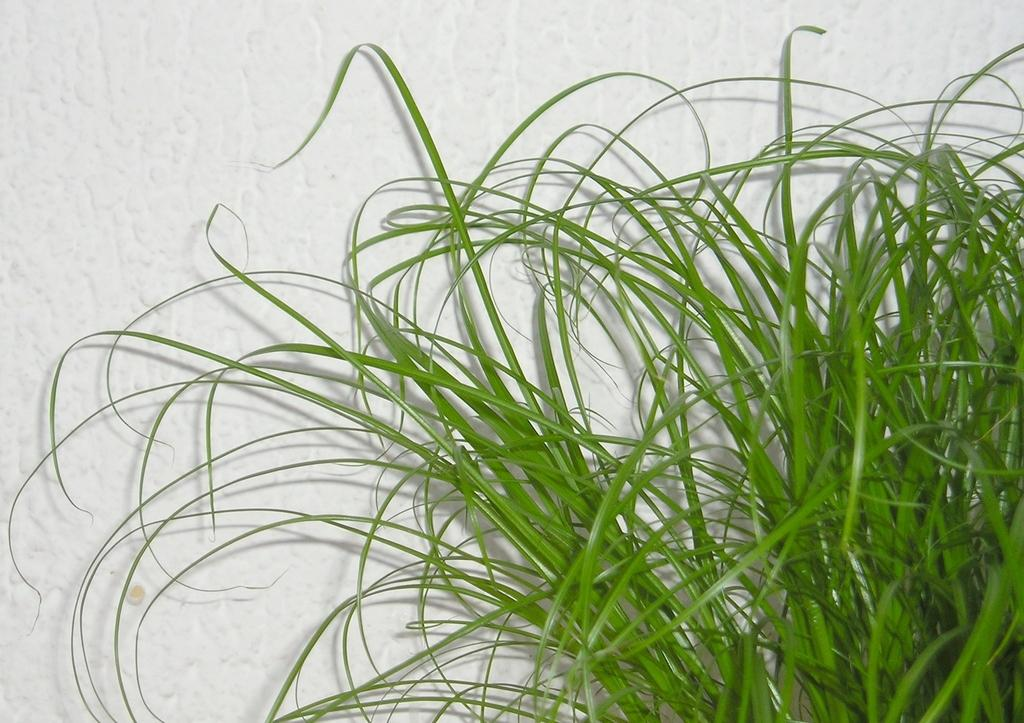What type of vegetation is visible in the image? There is green grass in the image. What color is the background of the image? The background of the image is white. How many chairs are present in the image? There are no chairs visible in the image. What type of current is flowing through the grass in the image? There is no current present in the image; it is a still image of green grass. 